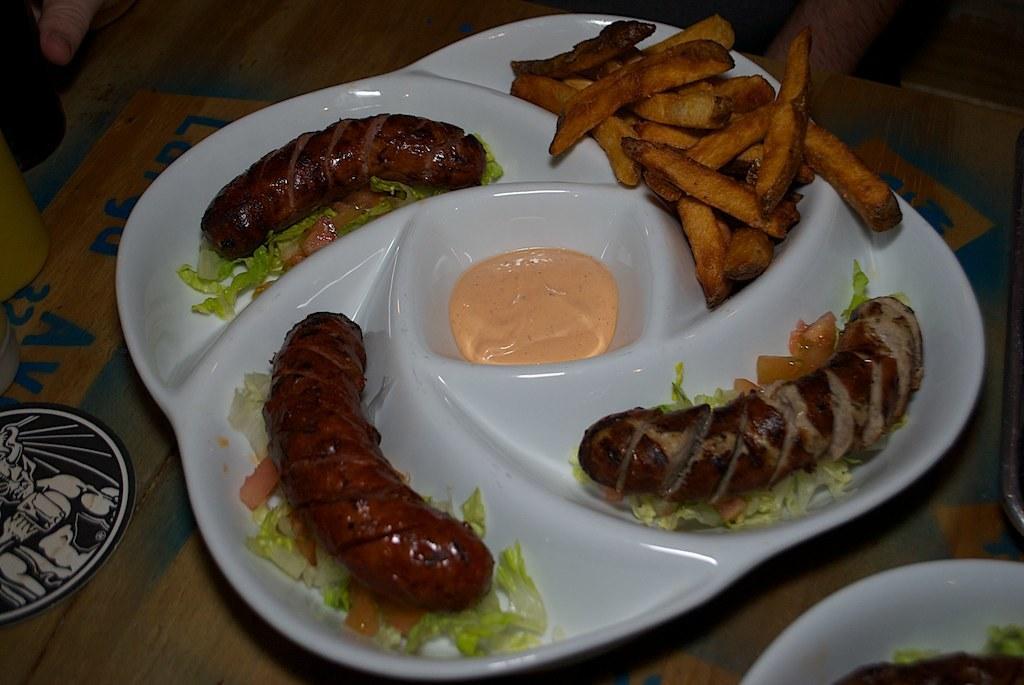How would you summarize this image in a sentence or two? In this picture there is a food placed in the white color plate. We can observe some fries in the plate. The plate was placed on the brown color table. 